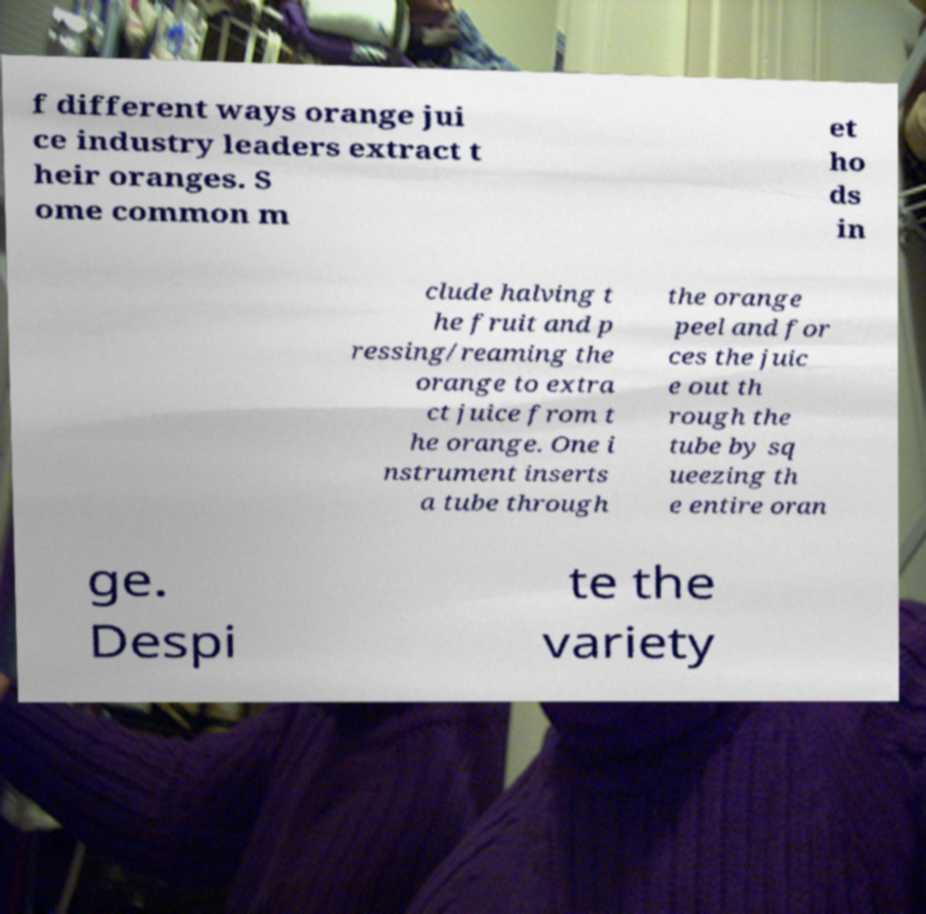There's text embedded in this image that I need extracted. Can you transcribe it verbatim? f different ways orange jui ce industry leaders extract t heir oranges. S ome common m et ho ds in clude halving t he fruit and p ressing/reaming the orange to extra ct juice from t he orange. One i nstrument inserts a tube through the orange peel and for ces the juic e out th rough the tube by sq ueezing th e entire oran ge. Despi te the variety 